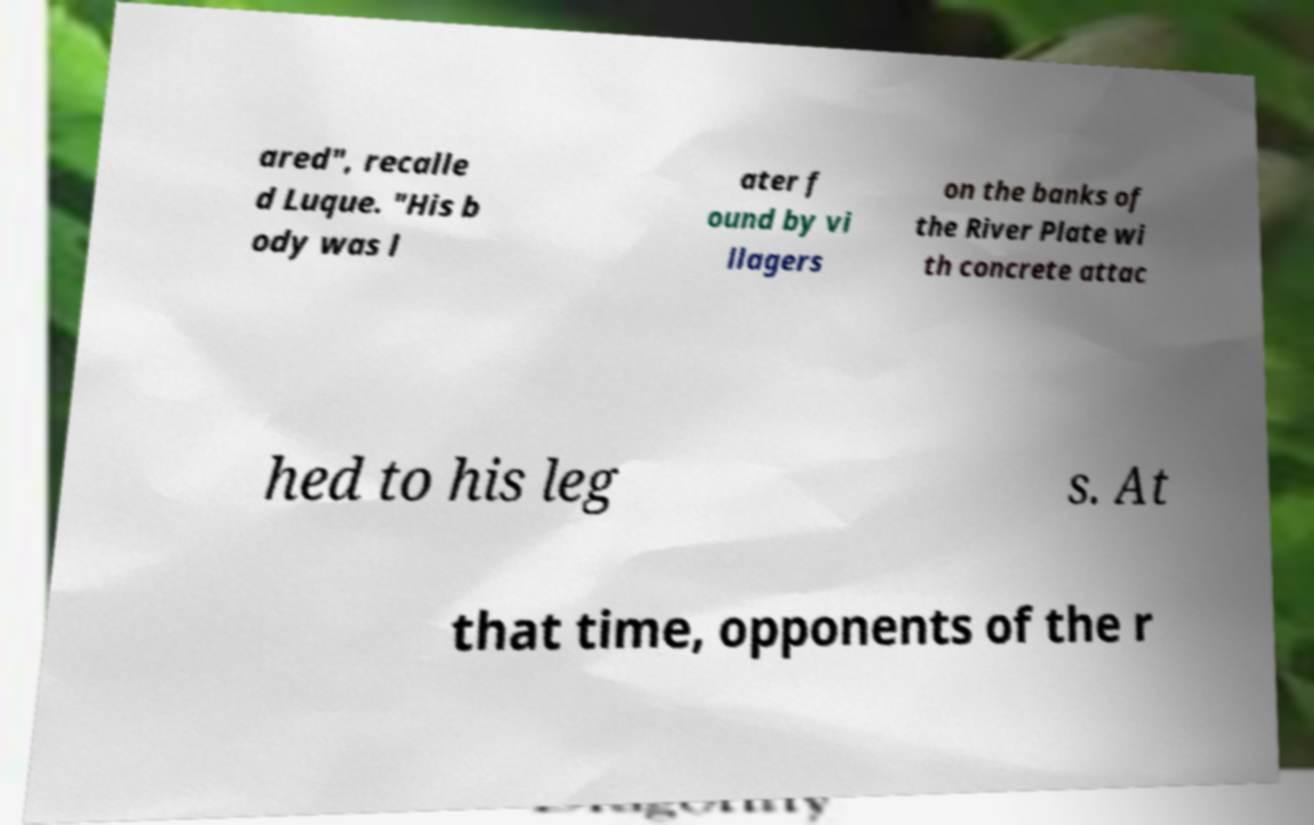Please identify and transcribe the text found in this image. ared", recalle d Luque. "His b ody was l ater f ound by vi llagers on the banks of the River Plate wi th concrete attac hed to his leg s. At that time, opponents of the r 